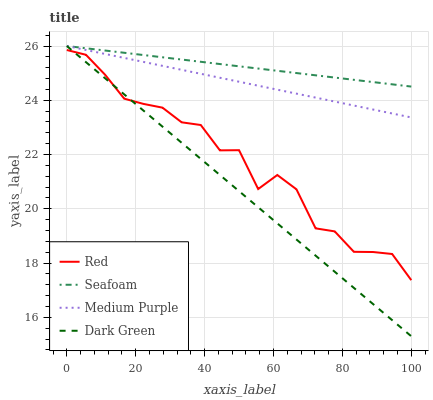Does Dark Green have the minimum area under the curve?
Answer yes or no. Yes. Does Seafoam have the maximum area under the curve?
Answer yes or no. Yes. Does Red have the minimum area under the curve?
Answer yes or no. No. Does Red have the maximum area under the curve?
Answer yes or no. No. Is Dark Green the smoothest?
Answer yes or no. Yes. Is Red the roughest?
Answer yes or no. Yes. Is Seafoam the smoothest?
Answer yes or no. No. Is Seafoam the roughest?
Answer yes or no. No. Does Red have the lowest value?
Answer yes or no. No. Does Dark Green have the highest value?
Answer yes or no. Yes. Does Red have the highest value?
Answer yes or no. No. Is Red less than Medium Purple?
Answer yes or no. Yes. Is Seafoam greater than Red?
Answer yes or no. Yes. Does Dark Green intersect Medium Purple?
Answer yes or no. Yes. Is Dark Green less than Medium Purple?
Answer yes or no. No. Is Dark Green greater than Medium Purple?
Answer yes or no. No. Does Red intersect Medium Purple?
Answer yes or no. No. 